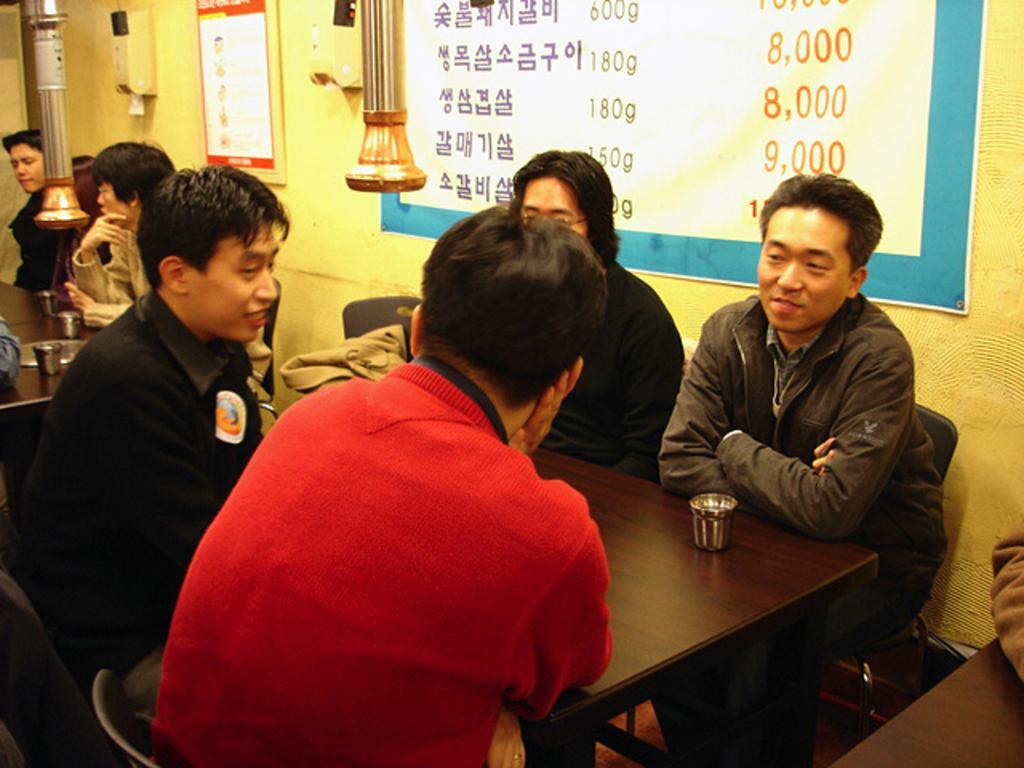Describe this image in one or two sentences. In this picture there is a table which is in black color, there are some people sitting on the chairs around the table, in the background there is a yellow color wall, on that wall there is a blue color poster. 